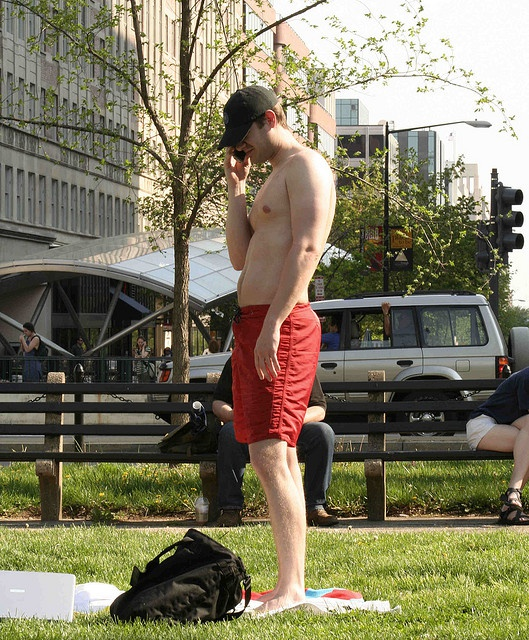Describe the objects in this image and their specific colors. I can see people in black, gray, maroon, and ivory tones, bench in black, gray, and darkgray tones, car in black, darkgray, and gray tones, bench in black, gray, and darkgreen tones, and backpack in black, gray, and darkgreen tones in this image. 